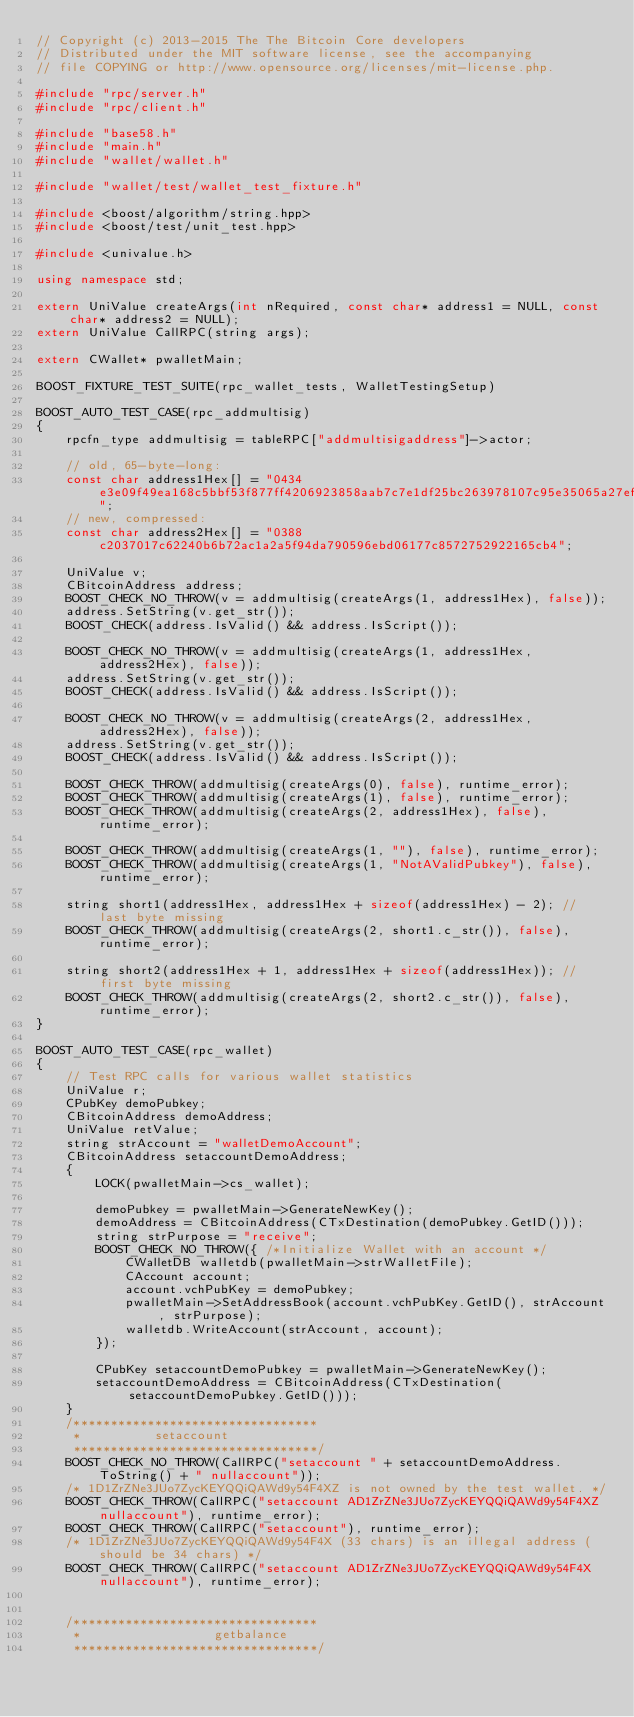Convert code to text. <code><loc_0><loc_0><loc_500><loc_500><_C++_>// Copyright (c) 2013-2015 The The Bitcoin Core developers
// Distributed under the MIT software license, see the accompanying
// file COPYING or http://www.opensource.org/licenses/mit-license.php.

#include "rpc/server.h"
#include "rpc/client.h"

#include "base58.h"
#include "main.h"
#include "wallet/wallet.h"

#include "wallet/test/wallet_test_fixture.h"

#include <boost/algorithm/string.hpp>
#include <boost/test/unit_test.hpp>

#include <univalue.h>

using namespace std;

extern UniValue createArgs(int nRequired, const char* address1 = NULL, const char* address2 = NULL);
extern UniValue CallRPC(string args);

extern CWallet* pwalletMain;

BOOST_FIXTURE_TEST_SUITE(rpc_wallet_tests, WalletTestingSetup)

BOOST_AUTO_TEST_CASE(rpc_addmultisig)
{
    rpcfn_type addmultisig = tableRPC["addmultisigaddress"]->actor;

    // old, 65-byte-long:
    const char address1Hex[] = "0434e3e09f49ea168c5bbf53f877ff4206923858aab7c7e1df25bc263978107c95e35065a27ef6f1b27222db0ec97e0e895eaca603d3ee0d4c060ce3d8a00286c8";
    // new, compressed:
    const char address2Hex[] = "0388c2037017c62240b6b72ac1a2a5f94da790596ebd06177c8572752922165cb4";

    UniValue v;
    CBitcoinAddress address;
    BOOST_CHECK_NO_THROW(v = addmultisig(createArgs(1, address1Hex), false));
    address.SetString(v.get_str());
    BOOST_CHECK(address.IsValid() && address.IsScript());

    BOOST_CHECK_NO_THROW(v = addmultisig(createArgs(1, address1Hex, address2Hex), false));
    address.SetString(v.get_str());
    BOOST_CHECK(address.IsValid() && address.IsScript());

    BOOST_CHECK_NO_THROW(v = addmultisig(createArgs(2, address1Hex, address2Hex), false));
    address.SetString(v.get_str());
    BOOST_CHECK(address.IsValid() && address.IsScript());

    BOOST_CHECK_THROW(addmultisig(createArgs(0), false), runtime_error);
    BOOST_CHECK_THROW(addmultisig(createArgs(1), false), runtime_error);
    BOOST_CHECK_THROW(addmultisig(createArgs(2, address1Hex), false), runtime_error);

    BOOST_CHECK_THROW(addmultisig(createArgs(1, ""), false), runtime_error);
    BOOST_CHECK_THROW(addmultisig(createArgs(1, "NotAValidPubkey"), false), runtime_error);

    string short1(address1Hex, address1Hex + sizeof(address1Hex) - 2); // last byte missing
    BOOST_CHECK_THROW(addmultisig(createArgs(2, short1.c_str()), false), runtime_error);

    string short2(address1Hex + 1, address1Hex + sizeof(address1Hex)); // first byte missing
    BOOST_CHECK_THROW(addmultisig(createArgs(2, short2.c_str()), false), runtime_error);
}

BOOST_AUTO_TEST_CASE(rpc_wallet)
{
    // Test RPC calls for various wallet statistics
    UniValue r;
    CPubKey demoPubkey;
    CBitcoinAddress demoAddress;
    UniValue retValue;
    string strAccount = "walletDemoAccount";
    CBitcoinAddress setaccountDemoAddress;
    {
        LOCK(pwalletMain->cs_wallet);

        demoPubkey = pwalletMain->GenerateNewKey();
        demoAddress = CBitcoinAddress(CTxDestination(demoPubkey.GetID()));
        string strPurpose = "receive";
        BOOST_CHECK_NO_THROW({ /*Initialize Wallet with an account */
            CWalletDB walletdb(pwalletMain->strWalletFile);
            CAccount account;
            account.vchPubKey = demoPubkey;
            pwalletMain->SetAddressBook(account.vchPubKey.GetID(), strAccount, strPurpose);
            walletdb.WriteAccount(strAccount, account);
        });

        CPubKey setaccountDemoPubkey = pwalletMain->GenerateNewKey();
        setaccountDemoAddress = CBitcoinAddress(CTxDestination(setaccountDemoPubkey.GetID()));
    }
    /*********************************
     * 			setaccount
     *********************************/
    BOOST_CHECK_NO_THROW(CallRPC("setaccount " + setaccountDemoAddress.ToString() + " nullaccount"));
    /* 1D1ZrZNe3JUo7ZycKEYQQiQAWd9y54F4XZ is not owned by the test wallet. */
    BOOST_CHECK_THROW(CallRPC("setaccount AD1ZrZNe3JUo7ZycKEYQQiQAWd9y54F4XZ nullaccount"), runtime_error);
    BOOST_CHECK_THROW(CallRPC("setaccount"), runtime_error);
    /* 1D1ZrZNe3JUo7ZycKEYQQiQAWd9y54F4X (33 chars) is an illegal address (should be 34 chars) */
    BOOST_CHECK_THROW(CallRPC("setaccount AD1ZrZNe3JUo7ZycKEYQQiQAWd9y54F4X nullaccount"), runtime_error);


    /*********************************
     *                  getbalance
     *********************************/</code> 